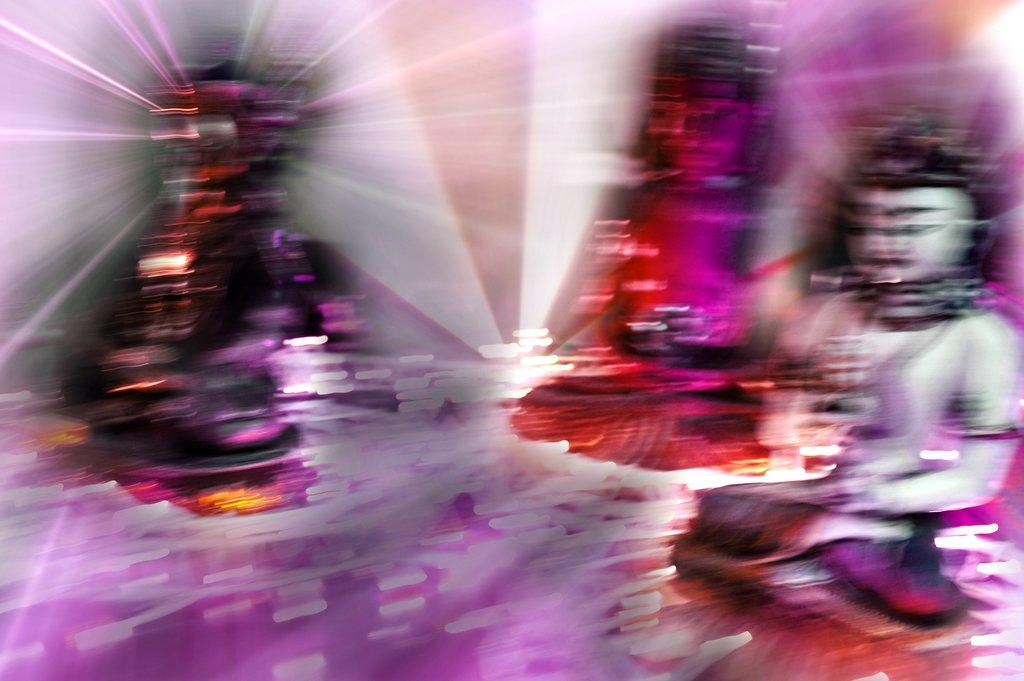What type of art is present in the image? There are sculptures in the image. What type of arm is holding the jar in the image? There is no arm or jar present in the image; it only features sculptures. 